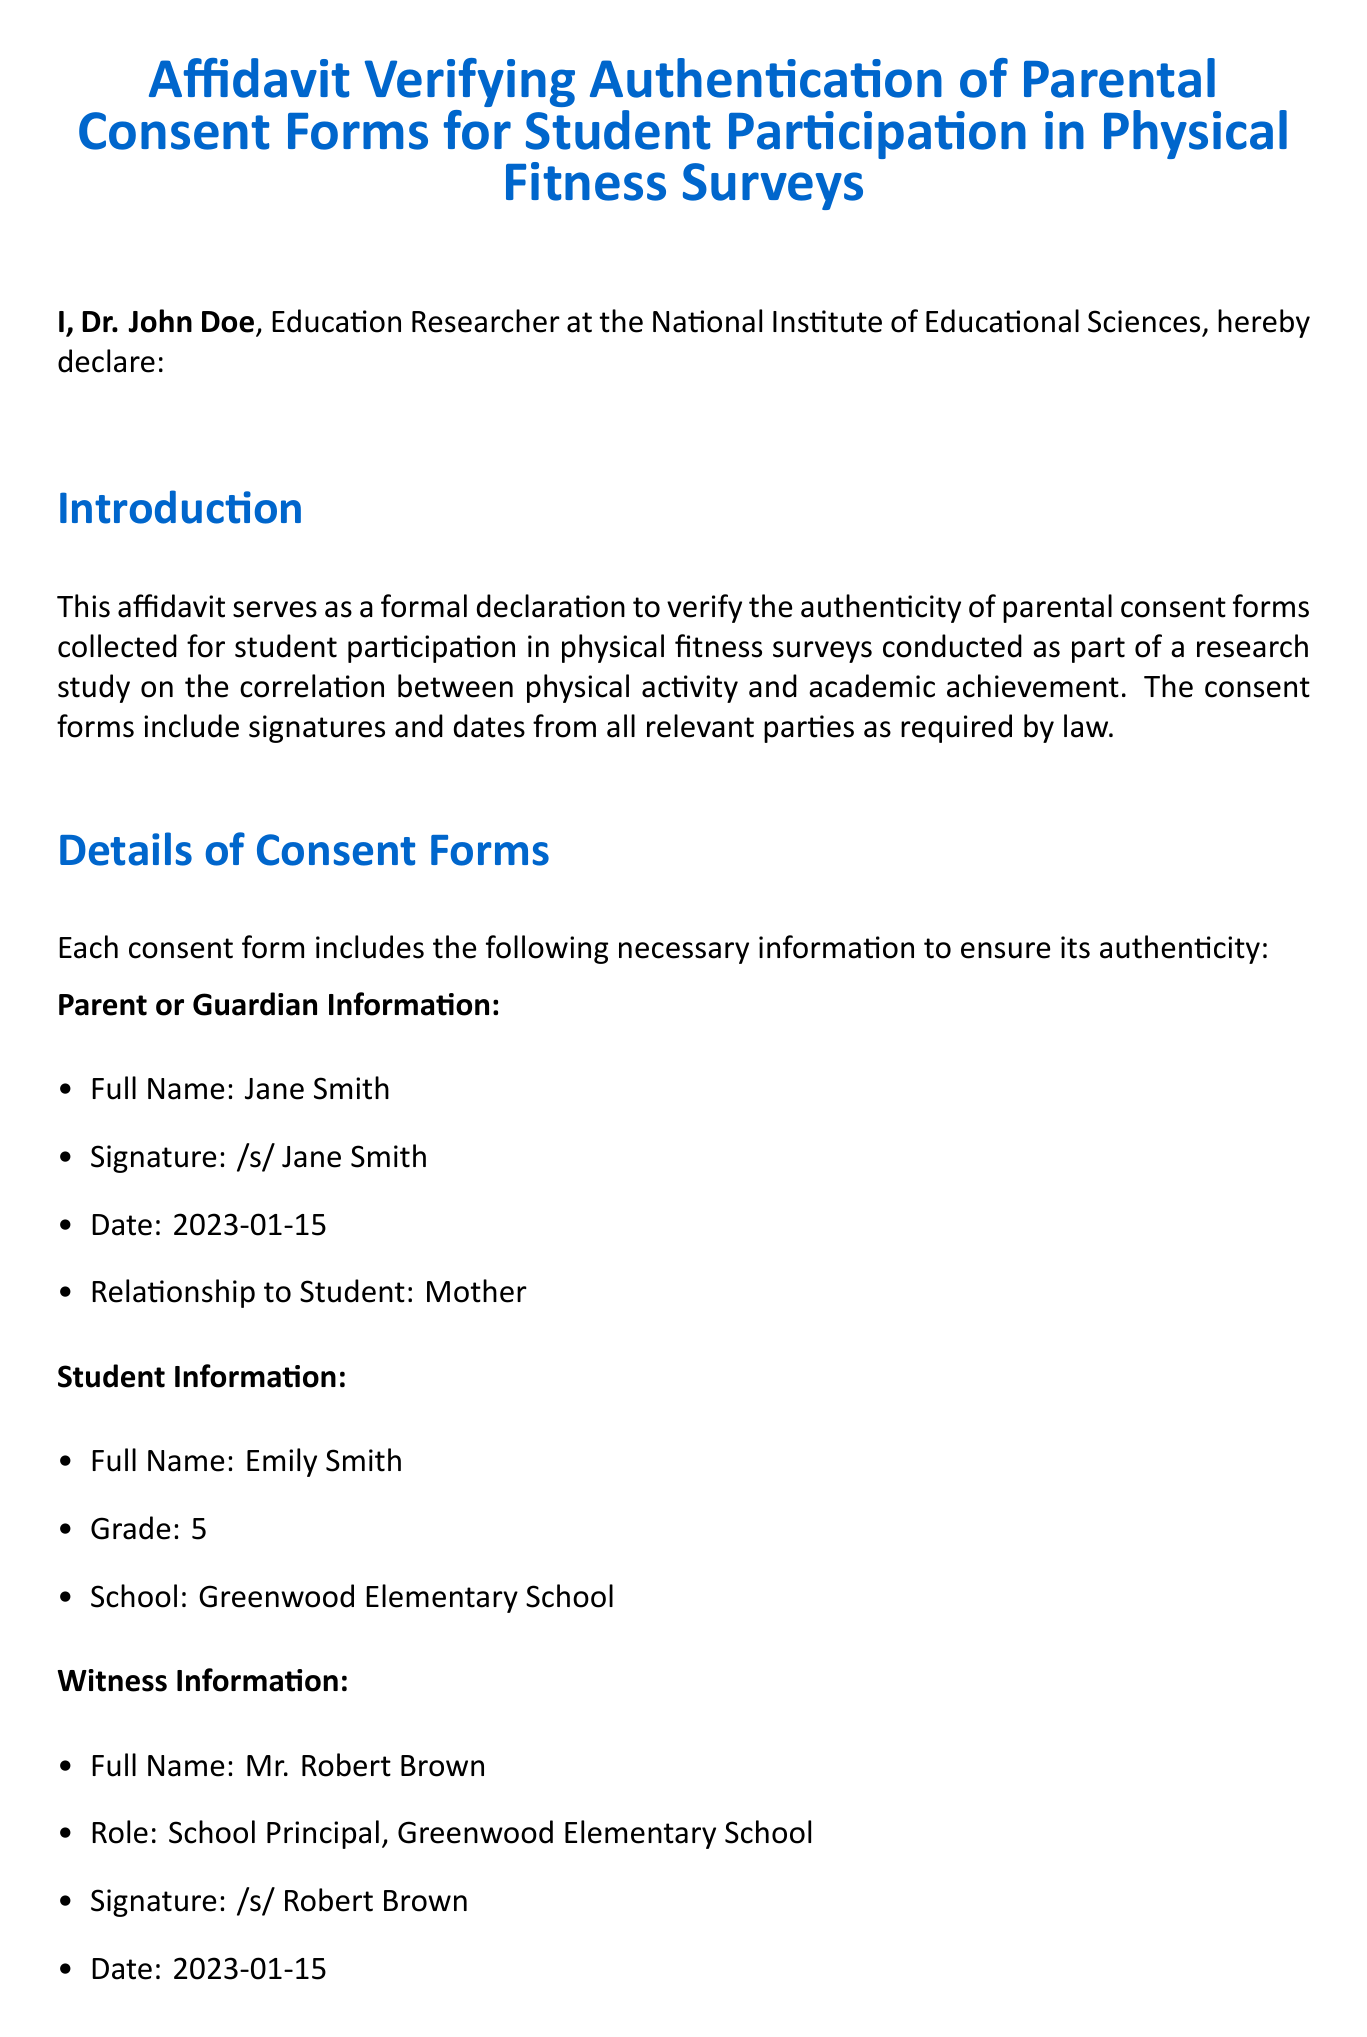What is the name of the researcher? The researcher is stated at the beginning of the affidavit, identified as Dr. John Doe.
Answer: Dr. John Doe What is the date of the parental consent form? The date on the consent form signed by the parent is listed in the document as 2023-01-15.
Answer: 2023-01-15 Who is the parent or guardian? The document specifies the parent or guardian's name as Jane Smith.
Answer: Jane Smith What is the relationship of the signer to the student? The relationship is explicitly mentioned in the document as the mother.
Answer: Mother When was the researcher confirmation signed? The date of the researcher's signature is mentioned as 2023-01-20.
Answer: 2023-01-20 What is the title of the document? The title of the document is presented at the top in a larger font.
Answer: Affidavit Verifying Authentication of Parental Consent Forms for Student Participation in Physical Fitness Surveys Who verified the affidavit? The document notes that Dr. John Doe verified the authenticity of the consent forms.
Answer: Dr. John Doe Who is the notary public? The notary public's name is provided at the bottom of the document as Linda Williams.
Answer: Linda Williams When does the notary's commission expire? The expiration date of the notary's commission is stated in the document as 2025-12-31.
Answer: 2025-12-31 